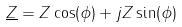<formula> <loc_0><loc_0><loc_500><loc_500>\underline { Z } = Z \cos ( \phi ) + j Z \sin ( \phi )</formula> 